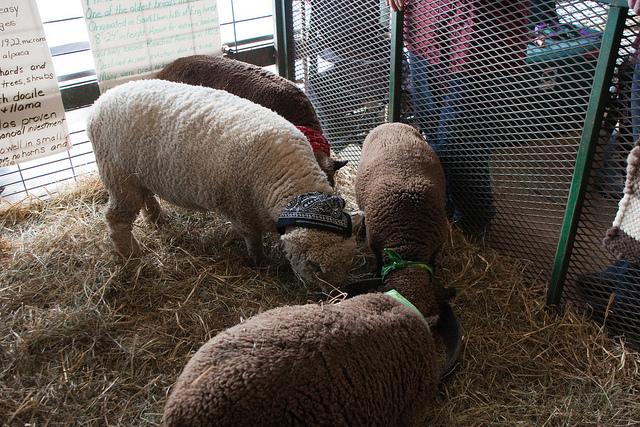What are the sheep eating?
Be succinct. Hay. Who put these sheep there?
Short answer required. Farmer. What are these people doing here?
Answer briefly. Looking at animals. 